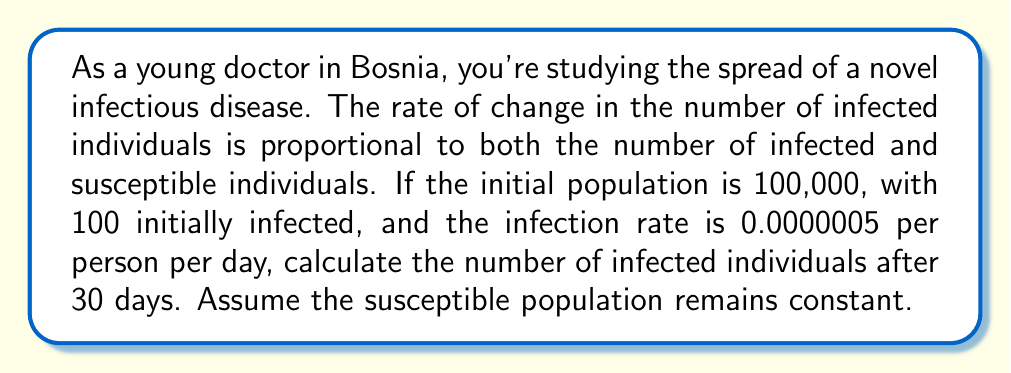Solve this math problem. Let's approach this step-by-step using a differential equation model:

1) Let $I(t)$ be the number of infected individuals at time $t$.

2) The differential equation for this model is:

   $$\frac{dI}{dt} = rSI$$

   where $r$ is the infection rate, $S$ is the number of susceptible individuals.

3) Given:
   - Total population: $N = 100,000$
   - Initially infected: $I(0) = 100$
   - Infection rate: $r = 0.0000005$ per person per day
   - Susceptible population (assumed constant): $S = N - I(0) = 99,900$

4) Substituting these values:

   $$\frac{dI}{dt} = 0.0000005 \cdot 99,900 \cdot I = 0.04995I$$

5) This is a separable differential equation. Solving it:

   $$\int \frac{dI}{I} = \int 0.04995 dt$$
   $$\ln|I| = 0.04995t + C$$

6) Using the initial condition $I(0) = 100$:

   $$\ln(100) = C$$
   $$C = 4.60517$$

7) Therefore, the general solution is:

   $$\ln|I| = 0.04995t + 4.60517$$
   $$I(t) = e^{0.04995t + 4.60517} = 100e^{0.04995t}$$

8) To find $I(30)$, we substitute $t = 30$:

   $$I(30) = 100e^{0.04995 \cdot 30} = 100e^{1.4985} \approx 446.58$$

9) Rounding to the nearest whole number:

   $$I(30) \approx 447$$
Answer: 447 infected individuals 